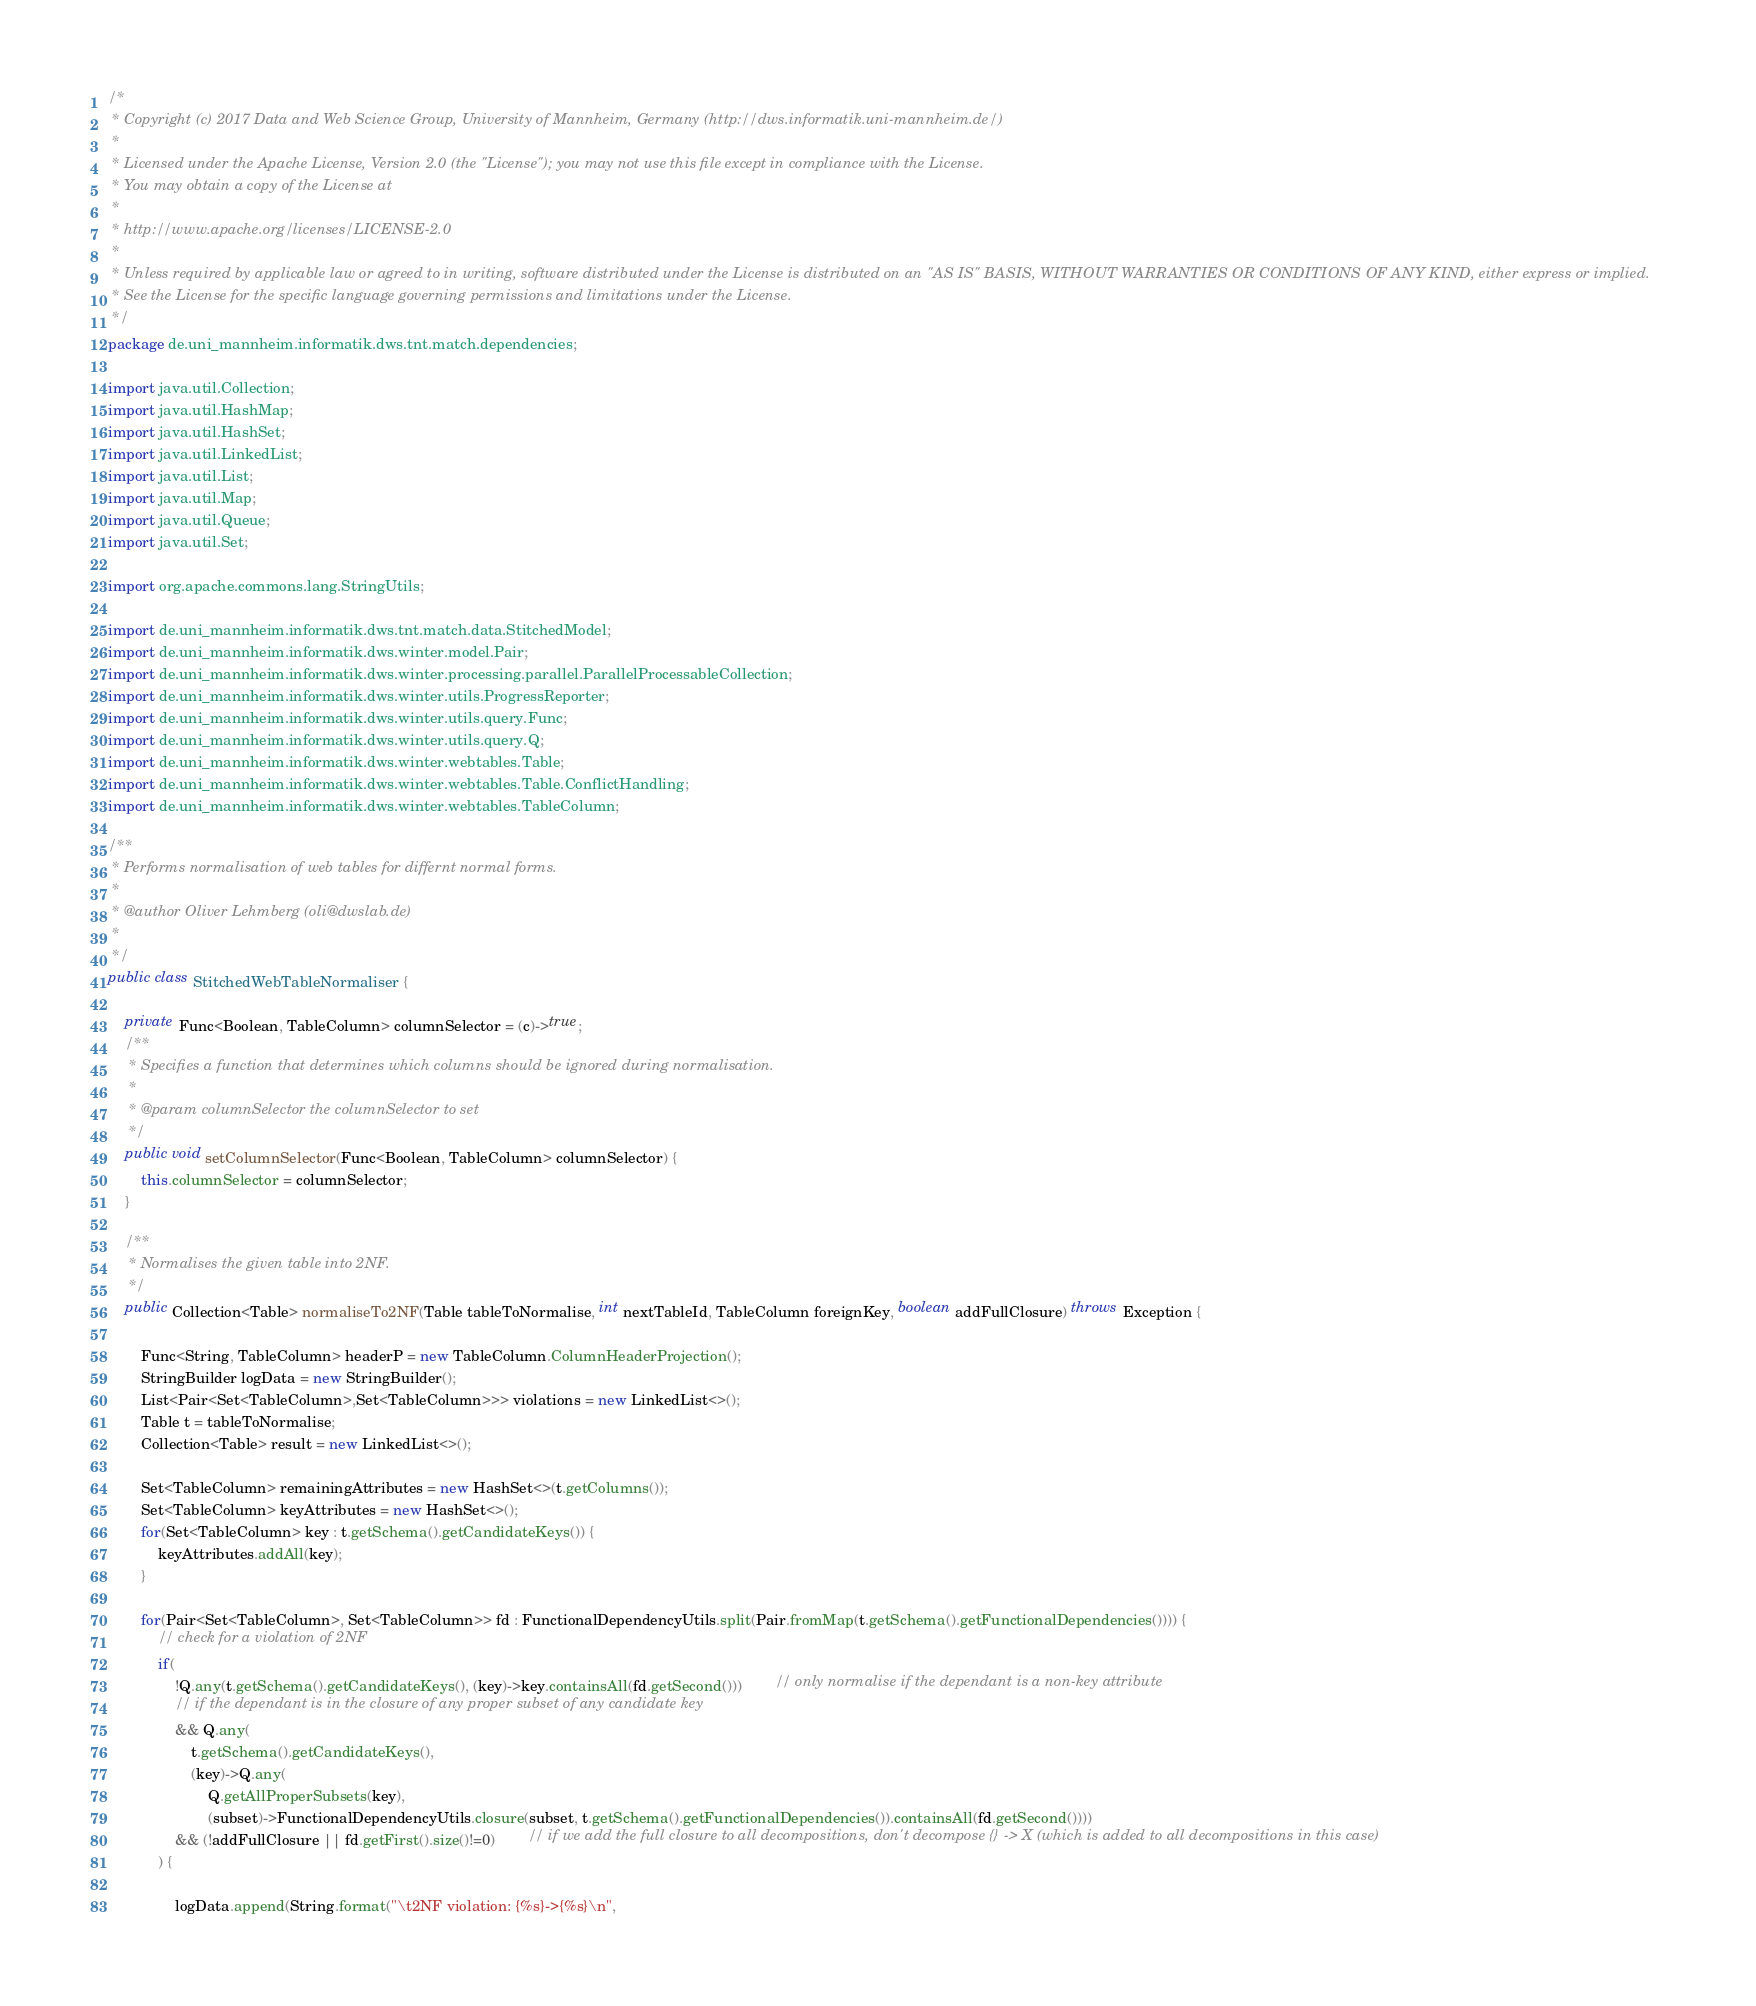<code> <loc_0><loc_0><loc_500><loc_500><_Java_>/*
 * Copyright (c) 2017 Data and Web Science Group, University of Mannheim, Germany (http://dws.informatik.uni-mannheim.de/)
 *
 * Licensed under the Apache License, Version 2.0 (the "License"); you may not use this file except in compliance with the License.
 * You may obtain a copy of the License at
 *
 * http://www.apache.org/licenses/LICENSE-2.0
 *
 * Unless required by applicable law or agreed to in writing, software distributed under the License is distributed on an "AS IS" BASIS, WITHOUT WARRANTIES OR CONDITIONS OF ANY KIND, either express or implied.
 * See the License for the specific language governing permissions and limitations under the License.
 */
package de.uni_mannheim.informatik.dws.tnt.match.dependencies;

import java.util.Collection;
import java.util.HashMap;
import java.util.HashSet;
import java.util.LinkedList;
import java.util.List;
import java.util.Map;
import java.util.Queue;
import java.util.Set;

import org.apache.commons.lang.StringUtils;

import de.uni_mannheim.informatik.dws.tnt.match.data.StitchedModel;
import de.uni_mannheim.informatik.dws.winter.model.Pair;
import de.uni_mannheim.informatik.dws.winter.processing.parallel.ParallelProcessableCollection;
import de.uni_mannheim.informatik.dws.winter.utils.ProgressReporter;
import de.uni_mannheim.informatik.dws.winter.utils.query.Func;
import de.uni_mannheim.informatik.dws.winter.utils.query.Q;
import de.uni_mannheim.informatik.dws.winter.webtables.Table;
import de.uni_mannheim.informatik.dws.winter.webtables.Table.ConflictHandling;
import de.uni_mannheim.informatik.dws.winter.webtables.TableColumn;

/**
 * Performs normalisation of web tables for differnt normal forms.
 * 
 * @author Oliver Lehmberg (oli@dwslab.de)
 *
 */
public class StitchedWebTableNormaliser {

	private Func<Boolean, TableColumn> columnSelector = (c)->true;
	/**
	 * Specifies a function that determines which columns should be ignored during normalisation.
	 * 
	 * @param columnSelector the columnSelector to set
	 */
	public void setColumnSelector(Func<Boolean, TableColumn> columnSelector) {
		this.columnSelector = columnSelector;
	}
	
	/**
	 * Normalises the given table into 2NF.
	 */
	public Collection<Table> normaliseTo2NF(Table tableToNormalise, int nextTableId, TableColumn foreignKey, boolean addFullClosure) throws Exception {

		Func<String, TableColumn> headerP = new TableColumn.ColumnHeaderProjection();
		StringBuilder logData = new StringBuilder();
		List<Pair<Set<TableColumn>,Set<TableColumn>>> violations = new LinkedList<>();
		Table t = tableToNormalise;
		Collection<Table> result = new LinkedList<>();

		Set<TableColumn> remainingAttributes = new HashSet<>(t.getColumns());
		Set<TableColumn> keyAttributes = new HashSet<>();
		for(Set<TableColumn> key : t.getSchema().getCandidateKeys()) {
			keyAttributes.addAll(key);
		}

		for(Pair<Set<TableColumn>, Set<TableColumn>> fd : FunctionalDependencyUtils.split(Pair.fromMap(t.getSchema().getFunctionalDependencies()))) {
			// check for a violation of 2NF
			if(
				!Q.any(t.getSchema().getCandidateKeys(), (key)->key.containsAll(fd.getSecond()))		// only normalise if the dependant is a non-key attribute
				// if the dependant is in the closure of any proper subset of any candidate key
				&& Q.any(
					t.getSchema().getCandidateKeys(), 
					(key)->Q.any(
						Q.getAllProperSubsets(key), 
						(subset)->FunctionalDependencyUtils.closure(subset, t.getSchema().getFunctionalDependencies()).containsAll(fd.getSecond())))
				&& (!addFullClosure || fd.getFirst().size()!=0)		// if we add the full closure to all decompositions, don't decompose {} -> X (which is added to all decompositions in this case)
			) {

				logData.append(String.format("\t2NF violation: {%s}->{%s}\n", </code> 